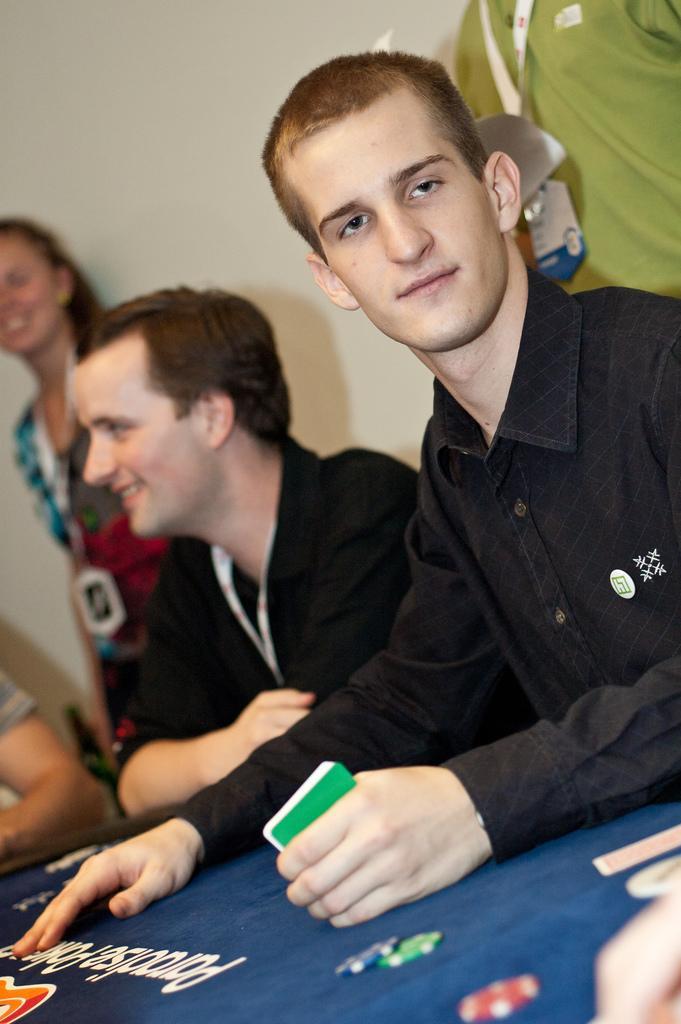Please provide a concise description of this image. In this image we can see two persons are sitting at the table and a man among them is holding cards in his hands. In the background there are few persons and wall. 